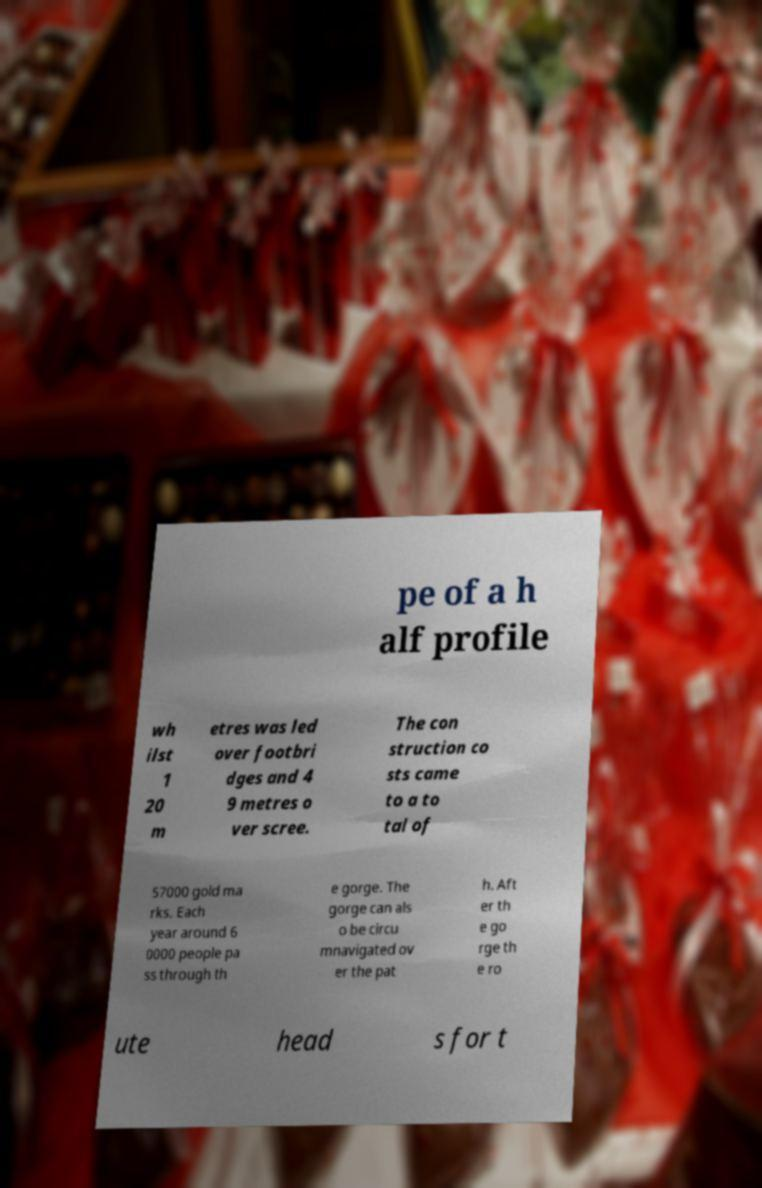There's text embedded in this image that I need extracted. Can you transcribe it verbatim? pe of a h alf profile wh ilst 1 20 m etres was led over footbri dges and 4 9 metres o ver scree. The con struction co sts came to a to tal of 57000 gold ma rks. Each year around 6 0000 people pa ss through th e gorge. The gorge can als o be circu mnavigated ov er the pat h. Aft er th e go rge th e ro ute head s for t 